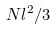Convert formula to latex. <formula><loc_0><loc_0><loc_500><loc_500>N l ^ { 2 } / 3</formula> 